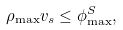<formula> <loc_0><loc_0><loc_500><loc_500>\rho _ { \max } v _ { s } \leq \phi _ { \max } ^ { S } ,</formula> 